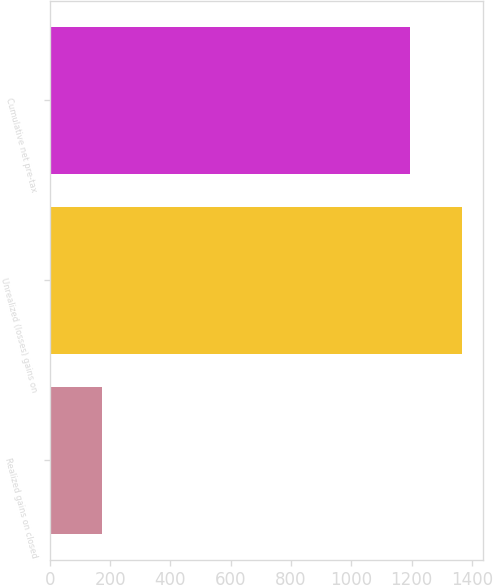Convert chart to OTSL. <chart><loc_0><loc_0><loc_500><loc_500><bar_chart><fcel>Realized gains on closed<fcel>Unrealized (losses) gains on<fcel>Cumulative net pre-tax<nl><fcel>174<fcel>1369<fcel>1195<nl></chart> 